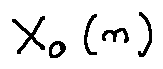<formula> <loc_0><loc_0><loc_500><loc_500>X _ { 0 } ( n )</formula> 